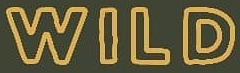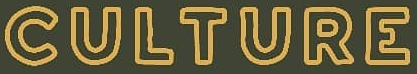Identify the words shown in these images in order, separated by a semicolon. WILD; CULTURE 